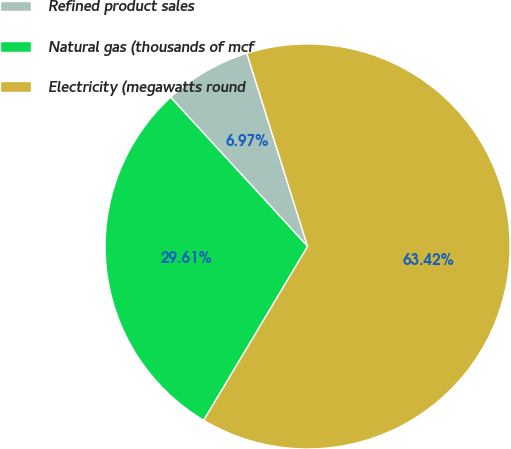Convert chart to OTSL. <chart><loc_0><loc_0><loc_500><loc_500><pie_chart><fcel>Refined product sales<fcel>Natural gas (thousands of mcf<fcel>Electricity (megawatts round<nl><fcel>6.97%<fcel>29.61%<fcel>63.43%<nl></chart> 